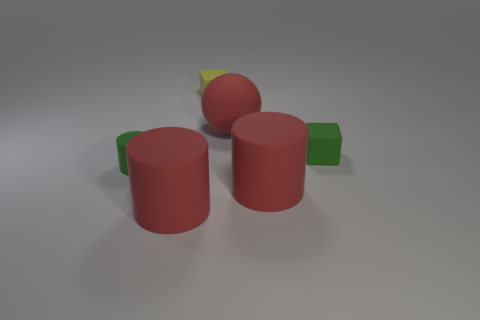Subtract all big red cylinders. How many cylinders are left? 1 Subtract 1 blocks. How many blocks are left? 1 Subtract all yellow blocks. How many blocks are left? 1 Add 4 small rubber cylinders. How many objects exist? 10 Subtract 0 blue cubes. How many objects are left? 6 Subtract all blocks. How many objects are left? 4 Subtract all blue spheres. Subtract all green cylinders. How many spheres are left? 1 Subtract all cyan spheres. How many green cylinders are left? 1 Subtract all green matte objects. Subtract all tiny green cubes. How many objects are left? 3 Add 3 tiny green blocks. How many tiny green blocks are left? 4 